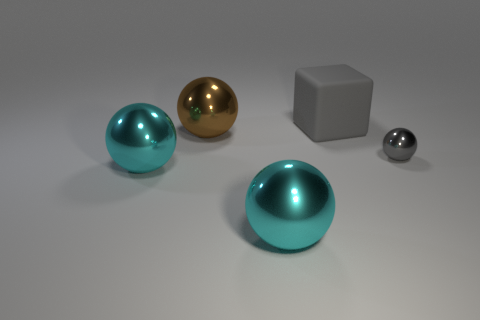What is the color of the small sphere?
Keep it short and to the point. Gray. How many objects are either yellow cylinders or tiny gray things?
Make the answer very short. 1. Are there any other things that are made of the same material as the big gray cube?
Offer a very short reply. No. Are there fewer cyan shiny objects that are behind the gray sphere than large purple metal things?
Give a very brief answer. No. Is the number of small balls in front of the large brown metal sphere greater than the number of tiny gray things that are on the left side of the tiny gray thing?
Make the answer very short. Yes. Are there any other things of the same color as the large matte cube?
Give a very brief answer. Yes. What is the gray thing behind the brown ball made of?
Your answer should be very brief. Rubber. Does the matte thing have the same size as the gray sphere?
Give a very brief answer. No. What number of other objects are there of the same size as the gray shiny thing?
Make the answer very short. 0. Does the tiny thing have the same color as the cube?
Keep it short and to the point. Yes. 